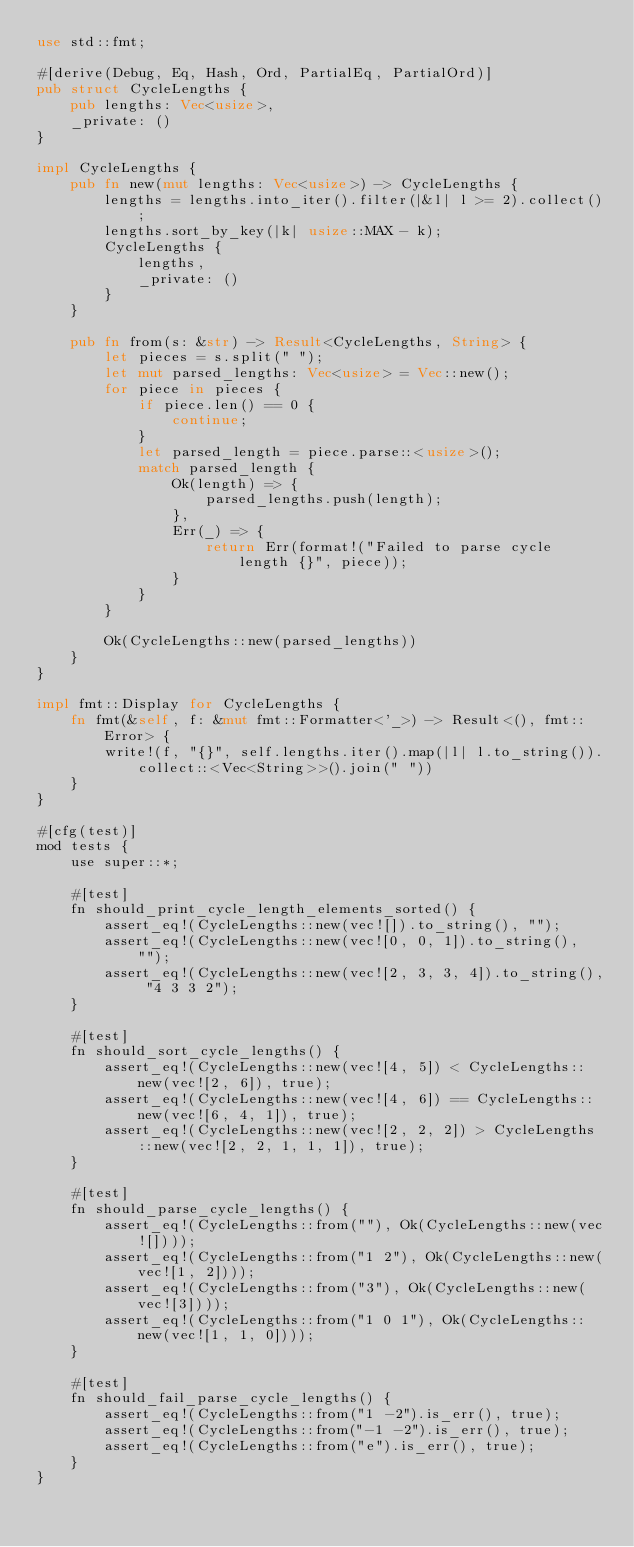<code> <loc_0><loc_0><loc_500><loc_500><_Rust_>use std::fmt;

#[derive(Debug, Eq, Hash, Ord, PartialEq, PartialOrd)]
pub struct CycleLengths {
    pub lengths: Vec<usize>,
    _private: ()
}

impl CycleLengths {
    pub fn new(mut lengths: Vec<usize>) -> CycleLengths {
        lengths = lengths.into_iter().filter(|&l| l >= 2).collect();
        lengths.sort_by_key(|k| usize::MAX - k);
        CycleLengths {
            lengths,
            _private: ()
        }
    }

    pub fn from(s: &str) -> Result<CycleLengths, String> {
        let pieces = s.split(" ");
        let mut parsed_lengths: Vec<usize> = Vec::new();
        for piece in pieces {
            if piece.len() == 0 {
                continue;
            }
            let parsed_length = piece.parse::<usize>();
            match parsed_length {
                Ok(length) => {
                    parsed_lengths.push(length);
                },
                Err(_) => {
                    return Err(format!("Failed to parse cycle length {}", piece));
                }
            }
        }

        Ok(CycleLengths::new(parsed_lengths))
    }
}

impl fmt::Display for CycleLengths {
    fn fmt(&self, f: &mut fmt::Formatter<'_>) -> Result<(), fmt::Error> {
        write!(f, "{}", self.lengths.iter().map(|l| l.to_string()).collect::<Vec<String>>().join(" "))
    }
}

#[cfg(test)]
mod tests {
    use super::*;

    #[test]
    fn should_print_cycle_length_elements_sorted() {
        assert_eq!(CycleLengths::new(vec![]).to_string(), "");
        assert_eq!(CycleLengths::new(vec![0, 0, 1]).to_string(), "");
        assert_eq!(CycleLengths::new(vec![2, 3, 3, 4]).to_string(), "4 3 3 2");
    }

    #[test]
    fn should_sort_cycle_lengths() {
        assert_eq!(CycleLengths::new(vec![4, 5]) < CycleLengths::new(vec![2, 6]), true);
        assert_eq!(CycleLengths::new(vec![4, 6]) == CycleLengths::new(vec![6, 4, 1]), true);
        assert_eq!(CycleLengths::new(vec![2, 2, 2]) > CycleLengths::new(vec![2, 2, 1, 1, 1]), true);
    }

    #[test]
    fn should_parse_cycle_lengths() {
        assert_eq!(CycleLengths::from(""), Ok(CycleLengths::new(vec![])));
        assert_eq!(CycleLengths::from("1 2"), Ok(CycleLengths::new(vec![1, 2])));
        assert_eq!(CycleLengths::from("3"), Ok(CycleLengths::new(vec![3])));
        assert_eq!(CycleLengths::from("1 0 1"), Ok(CycleLengths::new(vec![1, 1, 0])));
    }

    #[test]
    fn should_fail_parse_cycle_lengths() {
        assert_eq!(CycleLengths::from("1 -2").is_err(), true);
        assert_eq!(CycleLengths::from("-1 -2").is_err(), true);
        assert_eq!(CycleLengths::from("e").is_err(), true);
    }
}

</code> 